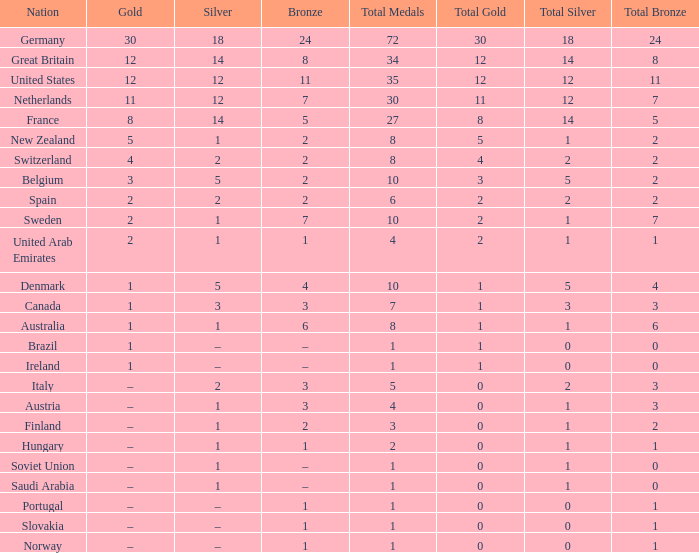What is the combined total amount when there is 1 silver and 7 bronze? 1.0. 